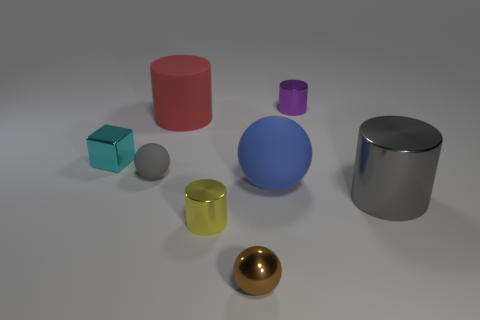Subtract 1 cylinders. How many cylinders are left? 3 Subtract all gray cylinders. How many cylinders are left? 3 Subtract all large red cylinders. How many cylinders are left? 3 Subtract all brown cylinders. Subtract all red balls. How many cylinders are left? 4 Add 1 red rubber cylinders. How many objects exist? 9 Subtract all blocks. How many objects are left? 7 Subtract all large gray metallic objects. Subtract all big blue matte spheres. How many objects are left? 6 Add 6 small metal objects. How many small metal objects are left? 10 Add 5 big red matte spheres. How many big red matte spheres exist? 5 Subtract 0 blue cylinders. How many objects are left? 8 